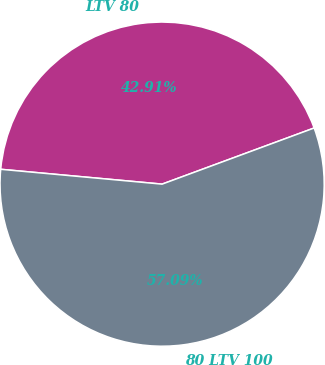<chart> <loc_0><loc_0><loc_500><loc_500><pie_chart><fcel>LTV 80<fcel>80 LTV 100<nl><fcel>42.91%<fcel>57.09%<nl></chart> 